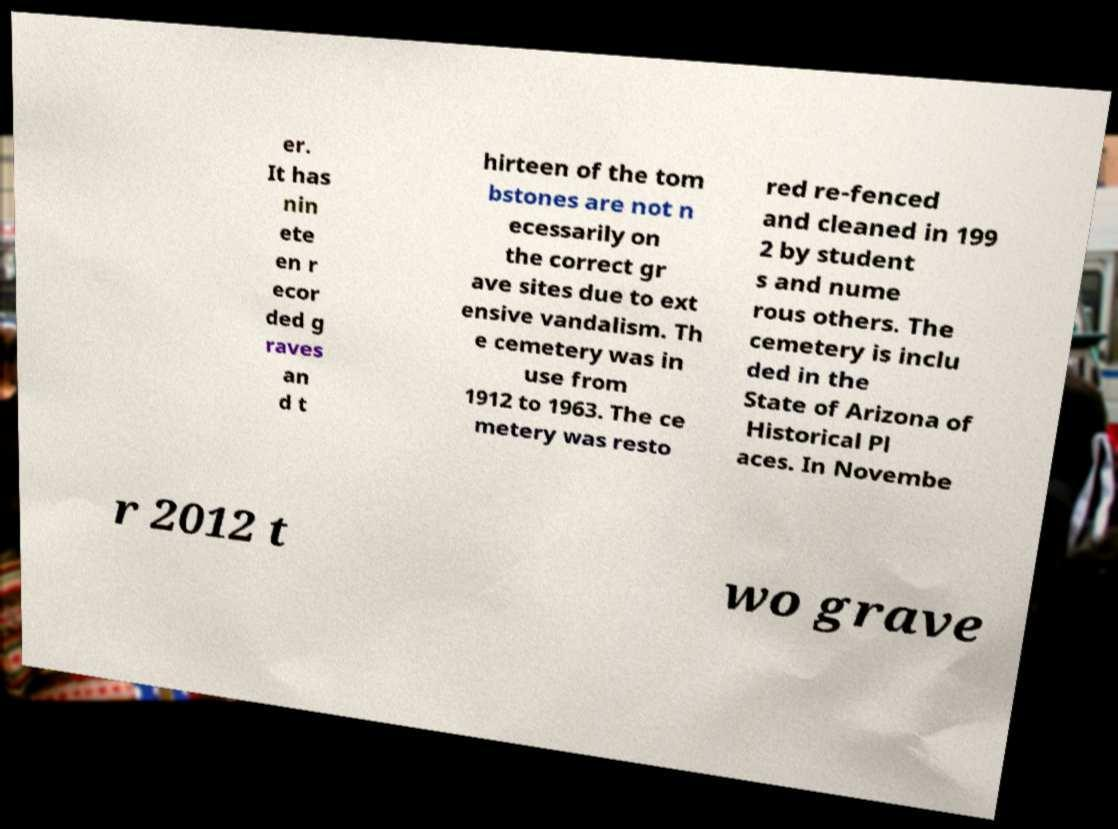Could you extract and type out the text from this image? er. It has nin ete en r ecor ded g raves an d t hirteen of the tom bstones are not n ecessarily on the correct gr ave sites due to ext ensive vandalism. Th e cemetery was in use from 1912 to 1963. The ce metery was resto red re-fenced and cleaned in 199 2 by student s and nume rous others. The cemetery is inclu ded in the State of Arizona of Historical Pl aces. In Novembe r 2012 t wo grave 